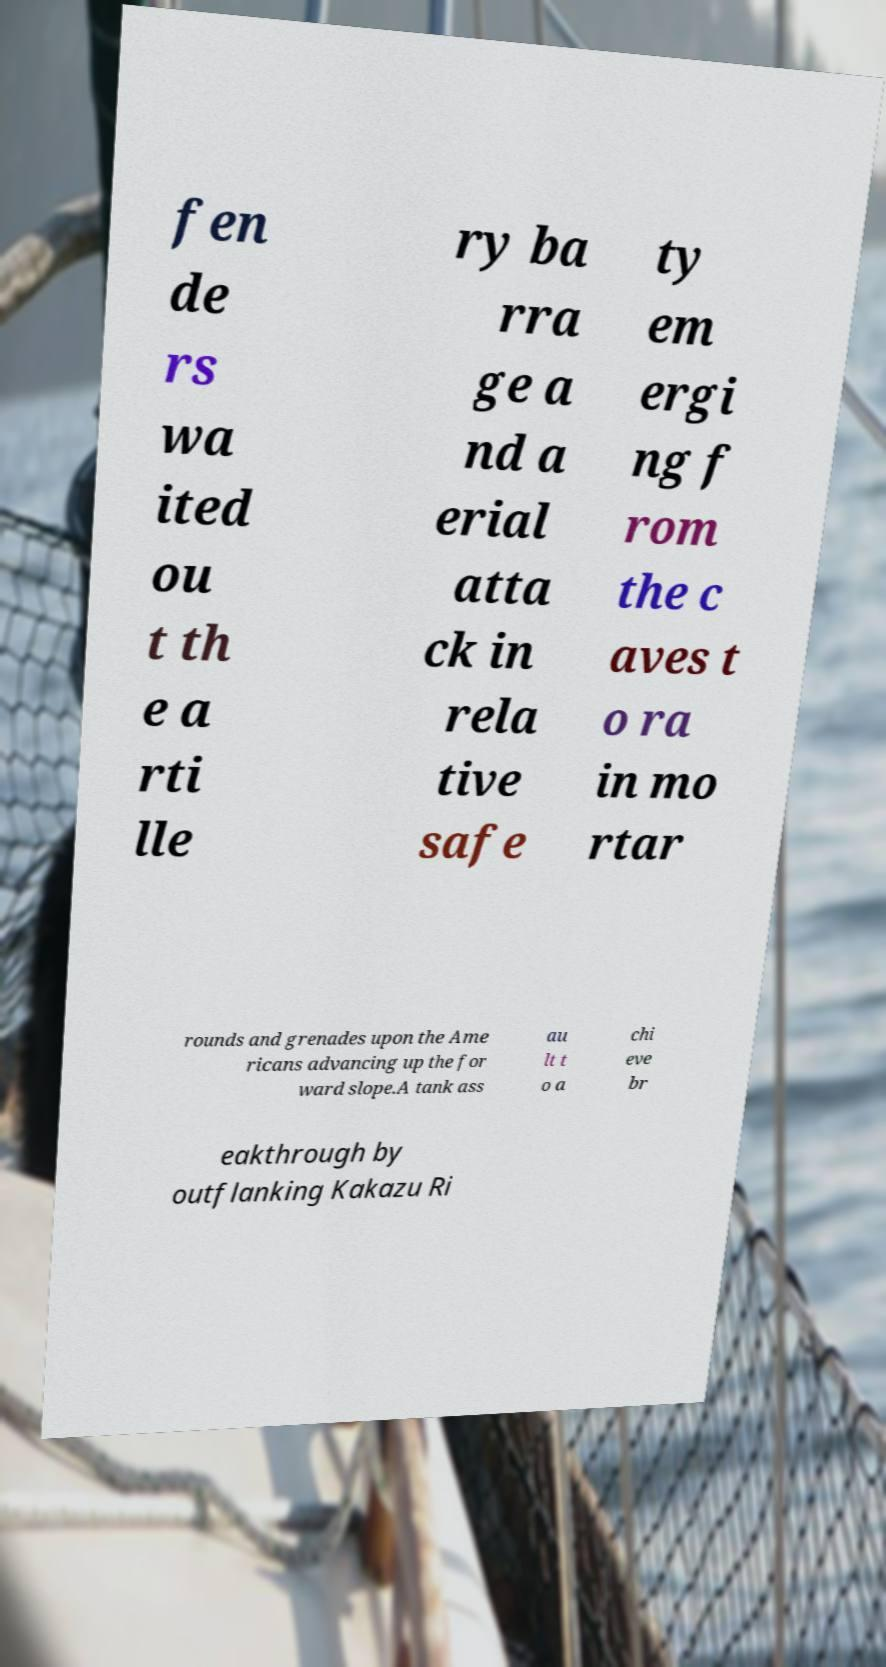Please read and relay the text visible in this image. What does it say? fen de rs wa ited ou t th e a rti lle ry ba rra ge a nd a erial atta ck in rela tive safe ty em ergi ng f rom the c aves t o ra in mo rtar rounds and grenades upon the Ame ricans advancing up the for ward slope.A tank ass au lt t o a chi eve br eakthrough by outflanking Kakazu Ri 